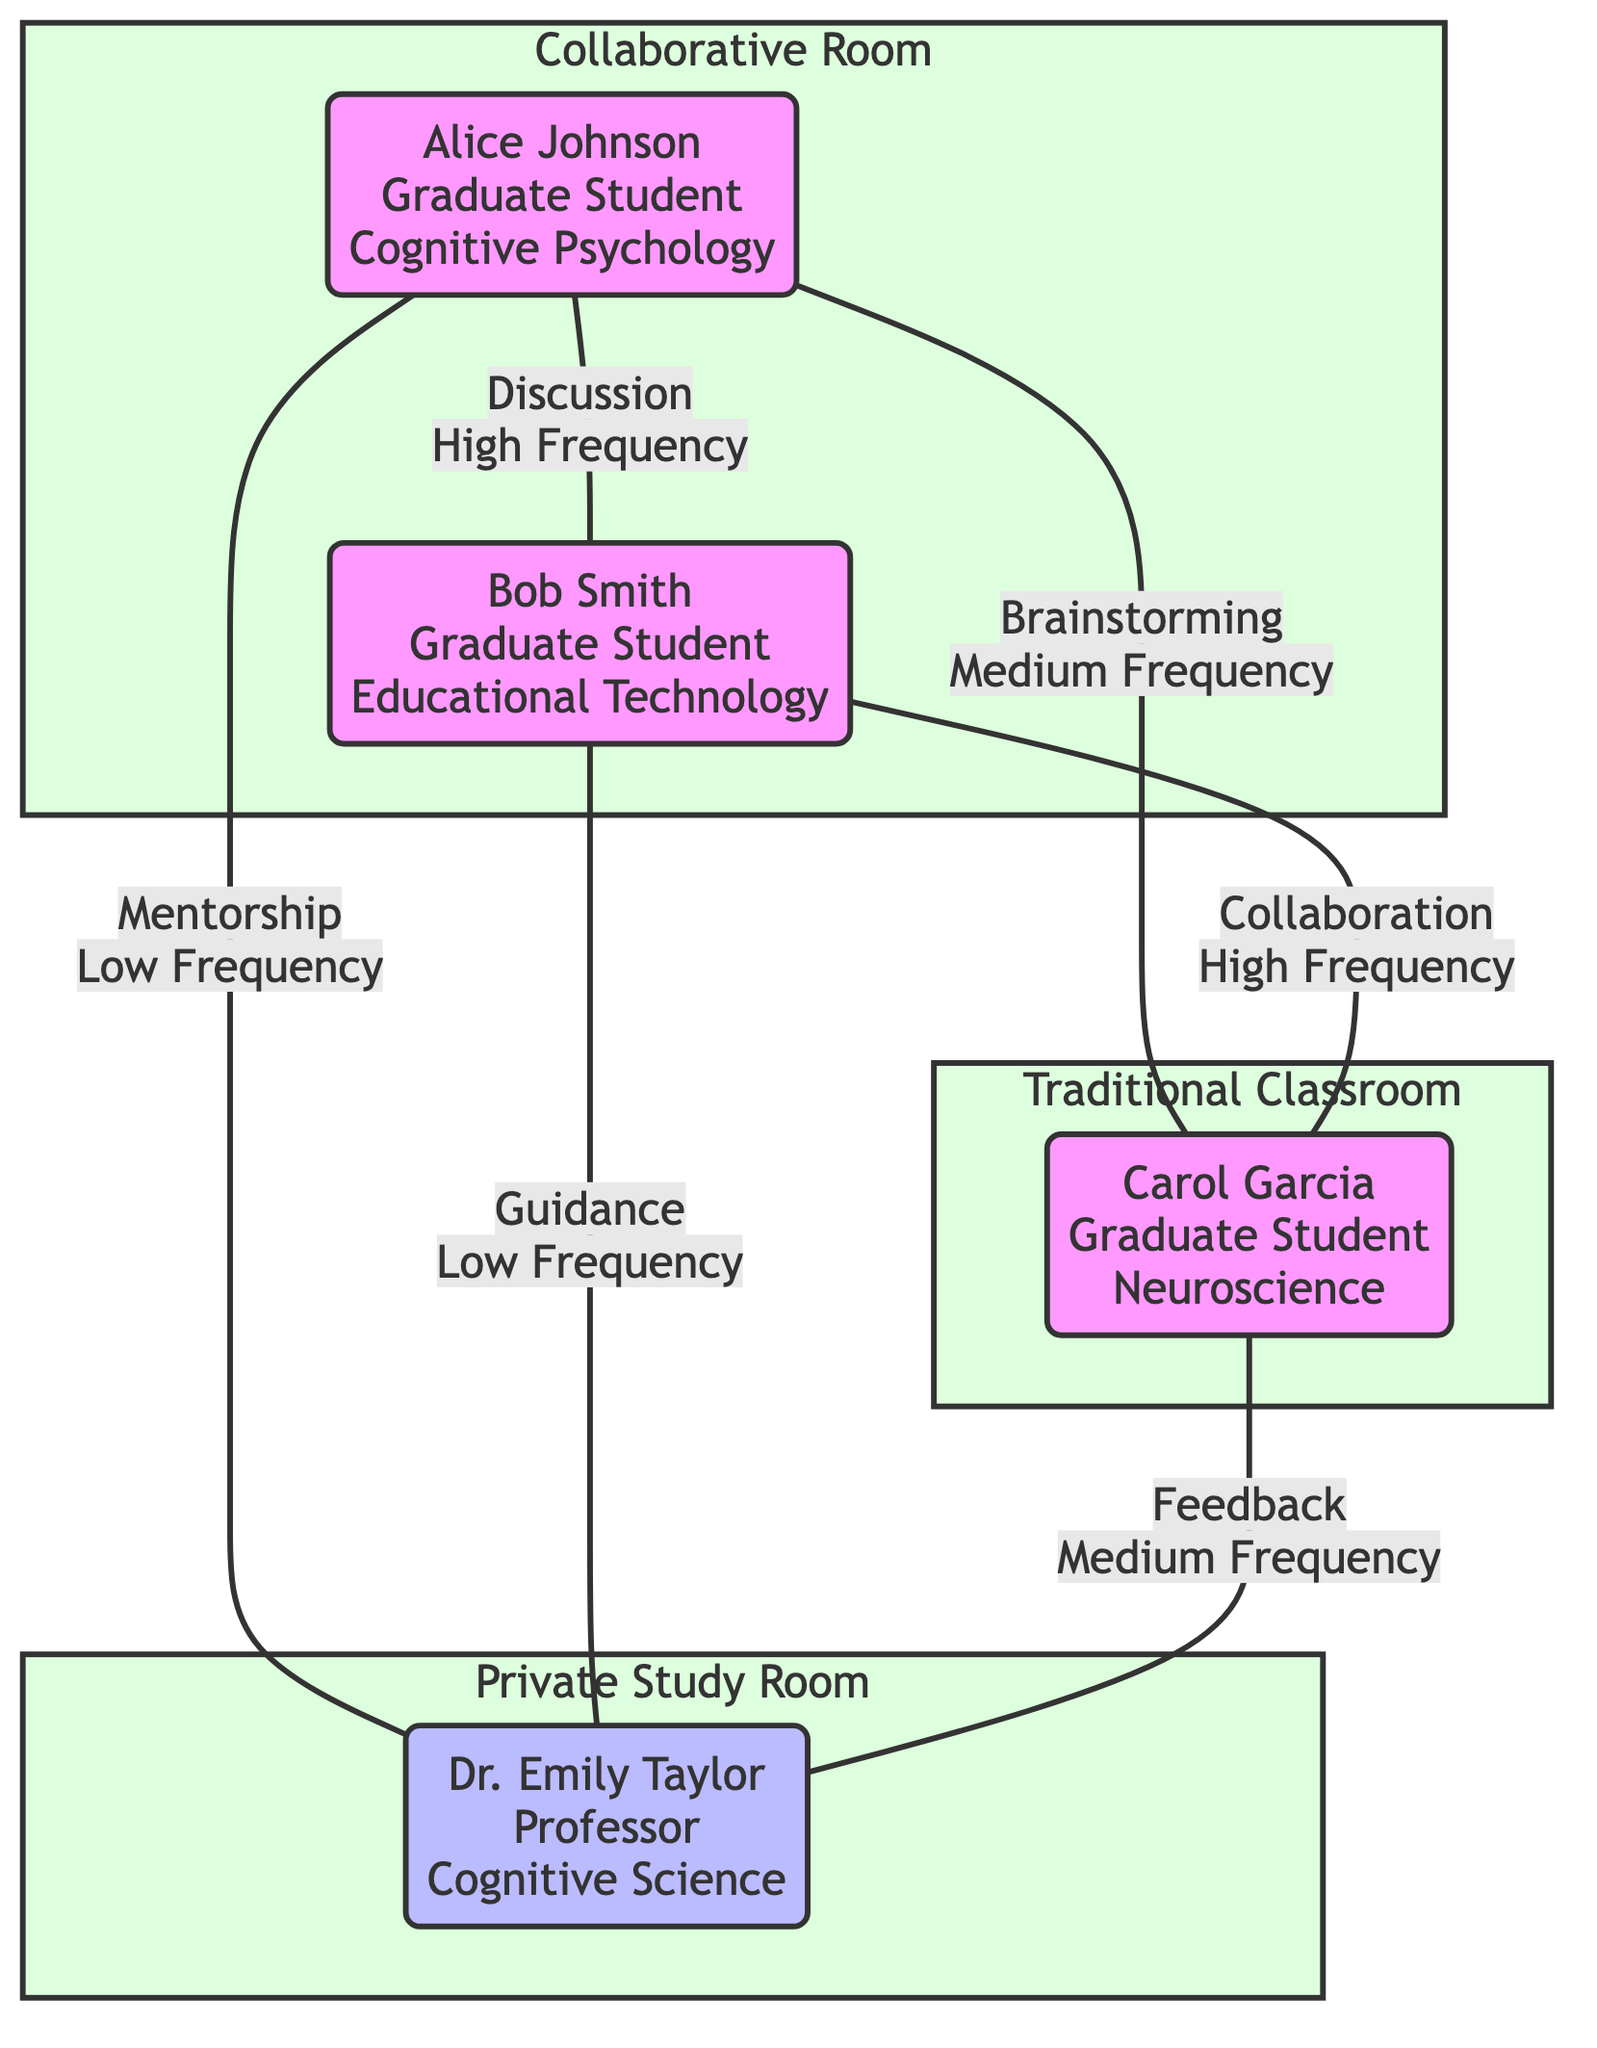What is the total number of nodes in the diagram? The diagram includes six nodes: three students, one facilitator, and three rooms. Counting all of them leads to a total of six nodes.
Answer: Six Which student has the highest interaction frequency with another student? Alice Johnson and Bob Smith each have high frequency interactions with each other in the Collaborative Room. They engage in discussions that are labeled as high frequency.
Answer: Alice Johnson, Bob Smith What type of interaction occurs between Student B and Student C? Examining the edge between Student B and Student C shows the interaction labeled as "Collaboration," which identifies the nature of their communication.
Answer: Collaboration In which room does Student A interact most frequently with Student B? The edge connecting Student A and Student B is in Room 1, categorized as a Collaborative Room, indicating their most frequent interactions occur there.
Answer: Room 1 How many interactions occur in Room 3? There are two interactions listed in Room 3 between students and the facilitator: mentorship from Student A and guidance from Student B, together totaling two interactions.
Answer: Two Which student receives feedback in the Traditional Classroom? Analyzing the edges indicates that Student C receives feedback from the facilitator in Room 2, affirming their interaction in the Traditional Classroom.
Answer: Carol Garcia What is the interaction type between the facilitator and Student B? The specified edge between the facilitator and Student B is labeled as "Guidance," thus identifying the nature of their interaction.
Answer: Guidance Which student has the focus area of Neuroscience? Among the nodes, Carol Garcia, identified as Student C, is explicitly mentioned as having a focus in Neuroscience.
Answer: Carol Garcia What features characterize Room 1? Room 1 is described as having an open layout, movable furniture, a large whiteboard, and natural light, indicating its collaborative attributes.
Answer: Open layout, movable furniture, large whiteboard, natural light 